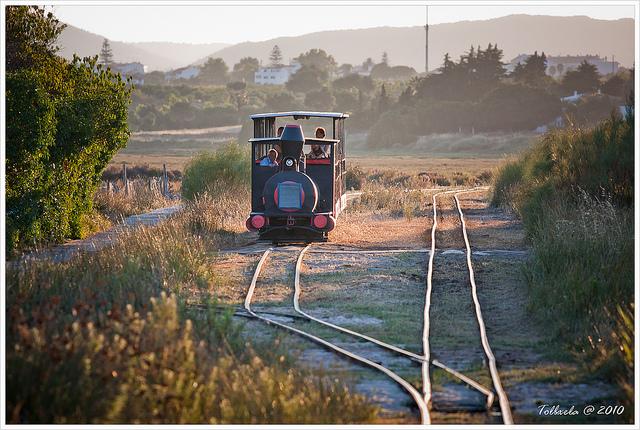How many people are on the train?
Give a very brief answer. 3. Is the train going fast?
Keep it brief. No. What is the train riding on?
Be succinct. Tracks. 